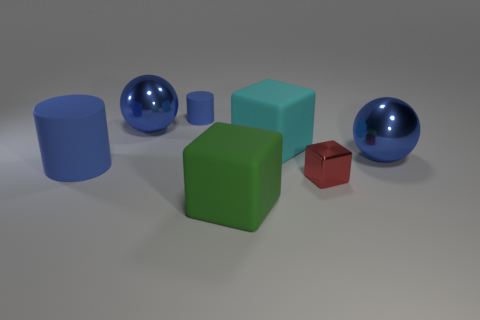There is a matte object on the right side of the big green matte block; does it have the same size as the cylinder behind the large blue cylinder?
Keep it short and to the point. No. How many blue objects have the same material as the tiny red object?
Keep it short and to the point. 2. There is a small matte cylinder behind the large shiny thing behind the large cyan object; how many tiny cylinders are left of it?
Ensure brevity in your answer.  0. Do the green rubber object and the tiny red metallic thing have the same shape?
Provide a succinct answer. Yes. Are there any large yellow objects of the same shape as the red thing?
Offer a terse response. No. The blue rubber object that is the same size as the cyan rubber block is what shape?
Your answer should be very brief. Cylinder. What is the material of the tiny red thing right of the blue rubber object in front of the big shiny thing to the right of the big green matte object?
Offer a terse response. Metal. Is the size of the green rubber cube the same as the cyan cube?
Provide a short and direct response. Yes. What is the material of the cyan thing?
Your answer should be very brief. Rubber. There is another cylinder that is the same color as the small rubber cylinder; what is it made of?
Give a very brief answer. Rubber. 